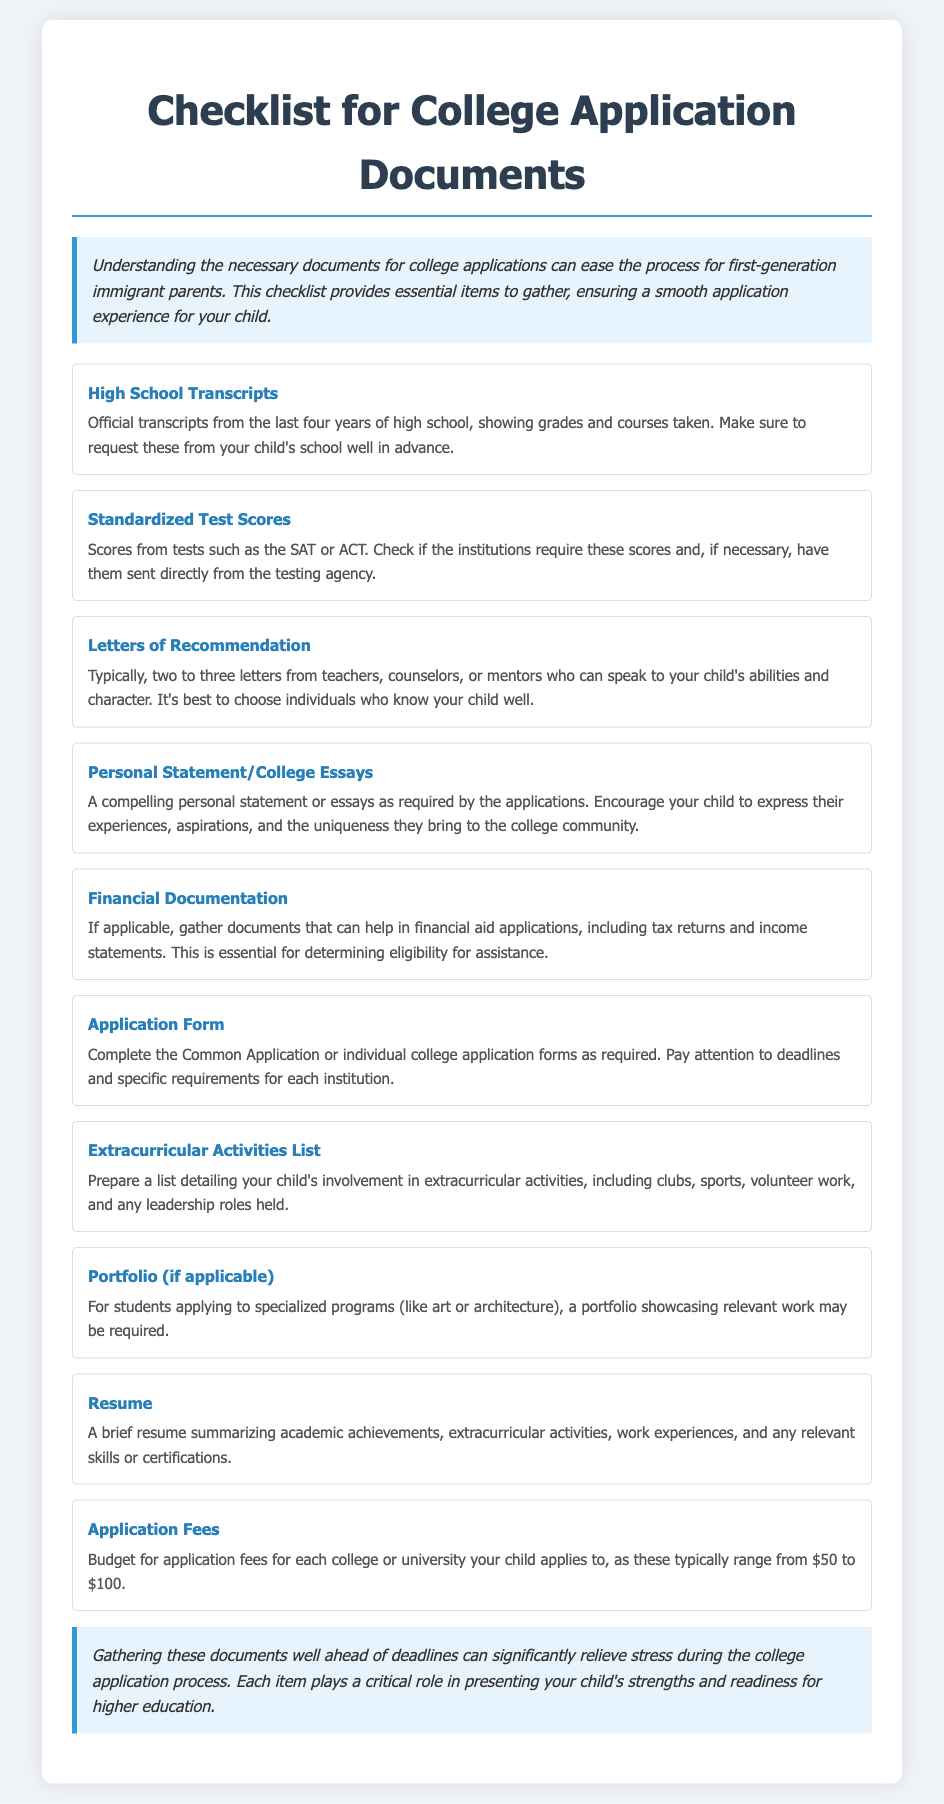What document is needed from the child's school? The document required from the school is the official transcripts showing grades and courses taken in the last four years.
Answer: High School Transcripts How many letters of recommendation are typically needed? Typically, two to three letters from teachers, counselors, or mentors are needed.
Answer: Two to three What is a key component of the personal statement? A key component involves expressing experiences, aspirations, and uniqueness.
Answer: Experiences and aspirations What type of list should be prepared regarding extracurricular activities? A list detailing involvement in clubs, sports, volunteer work, and leadership roles should be prepared.
Answer: Extracurricular Activities List What is the budget range for application fees? The budget range for application fees for colleges or universities is usually $50 to $100.
Answer: $50 to $100 